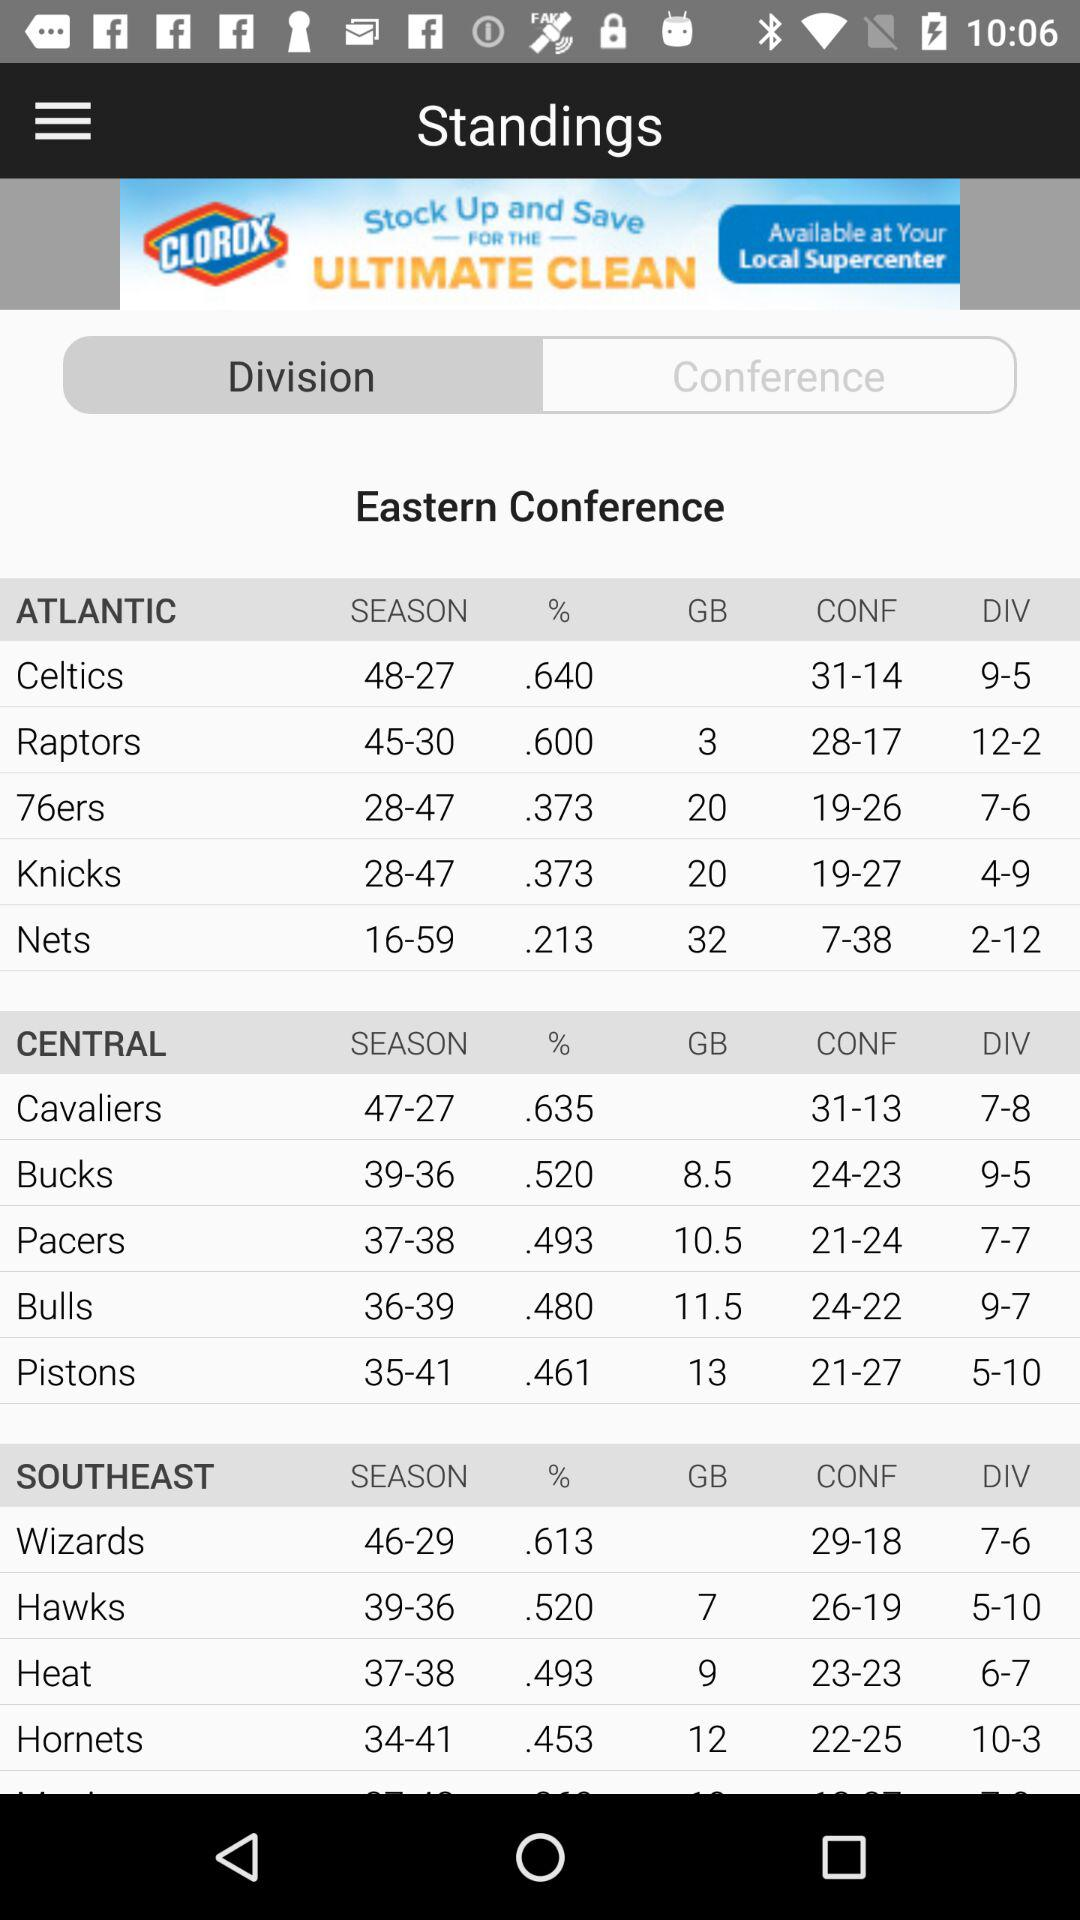What is the division of "Celtics"? The division is 9-5. 